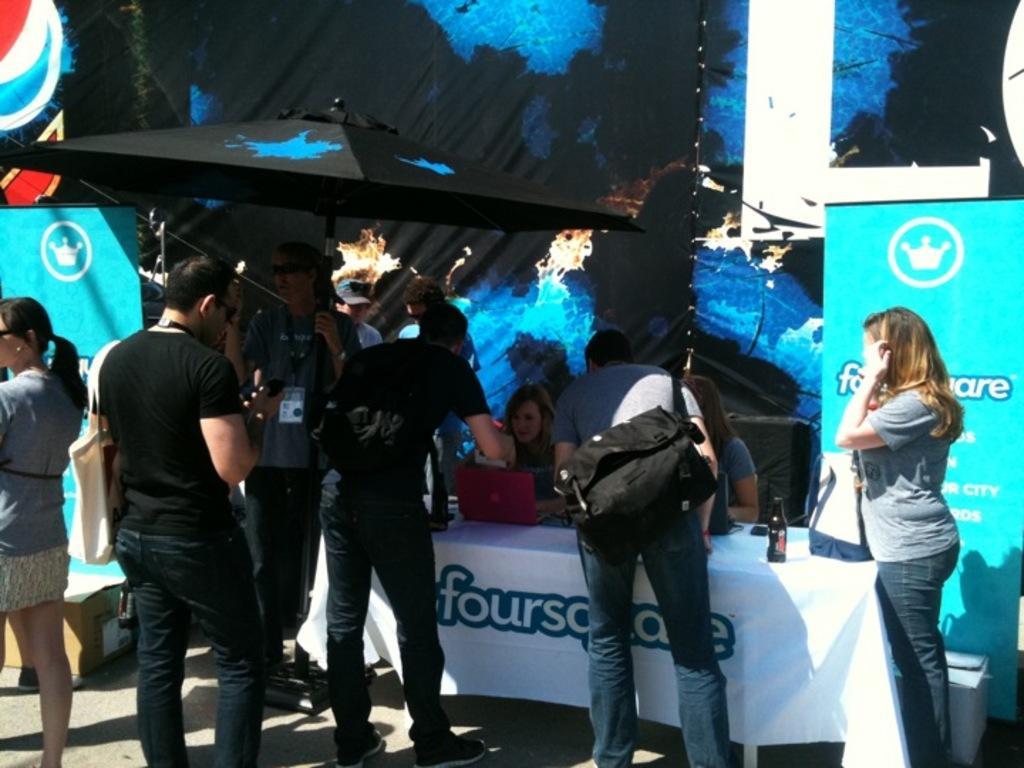Please provide a concise description of this image. In the picture I can see people are standing among them some are wearing bags. I can also see a table on which I can see some objects. I can also see banners and some other objects on the ground. 